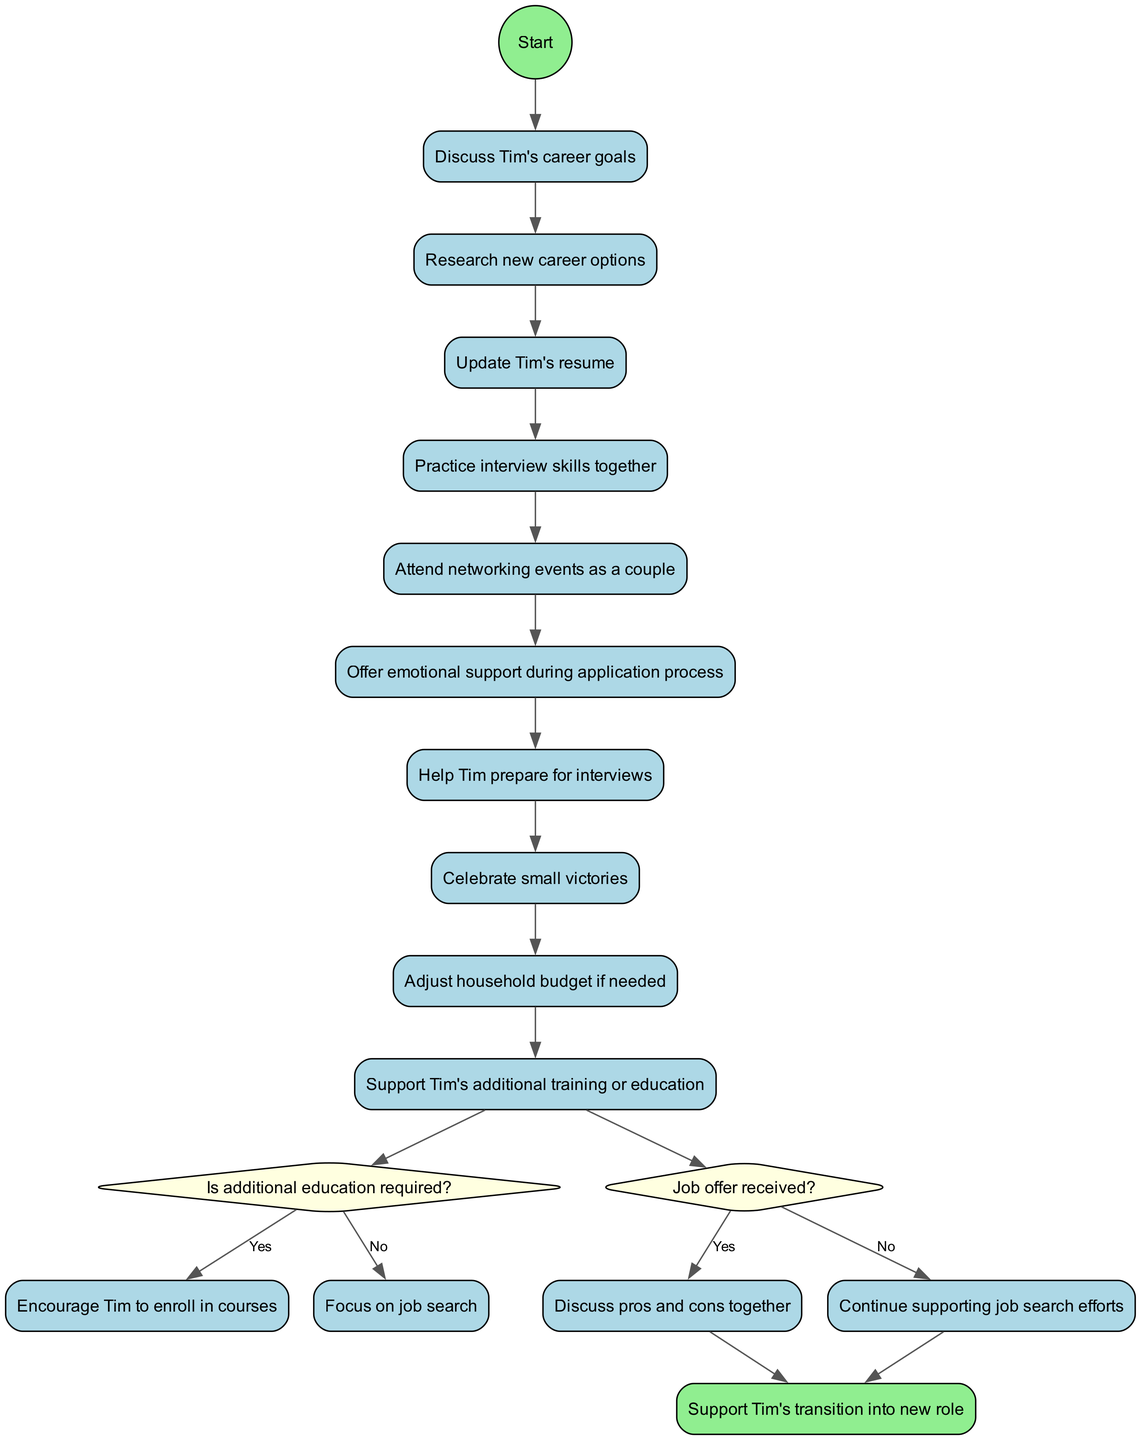What is the initial activity in the diagram? The initial activity node labeled "Discuss Tim's career goals" is connected to the start node, indicating it is the first action to take.
Answer: Discuss Tim's career goals How many activities are represented in the diagram? There are a total of 9 activities listed, including both the initial and the final nodes. Each activity is distinctly labeled in the diagram.
Answer: 9 What does the decision "Is additional education required?" lead to if answered "Yes"? If "Yes" is chosen for the decision, the flow leads to the activity "Encourage Tim to enroll in courses," which shows the next step if extra education is needed.
Answer: Encourage Tim to enroll in courses What is the outcome of the decision "Job offer received?" if answered "No"? Answering "No" directs the flow to the activity "Continue supporting job search efforts," indicating that the process continues without a job offer.
Answer: Continue supporting job search efforts What is the final node in the diagram? The final node is labeled "Support Tim's transition into new role," indicating that this is the end point for the process after all activities and decisions have been made.
Answer: Support Tim's transition into new role How do the activities relate to the decision nodes? The activities are connected to the decision nodes at the end of the activity sequence; specifically, the last activity leads into the first decision node, showing that the decisions are based on prior activities.
Answer: Connected after the last activity What is one of the activities that involves emotional support? "Offer emotional support during application process" is one of the activities explicitly intended to provide emotional backing to Tim during the job application phase.
Answer: Offer emotional support during application process Which activity comes immediately after "Update Tim's resume"? The next activity that follows "Update Tim's resume" is "Practice interview skills together," showing the sequential flow of supporting actions.
Answer: Practice interview skills together 